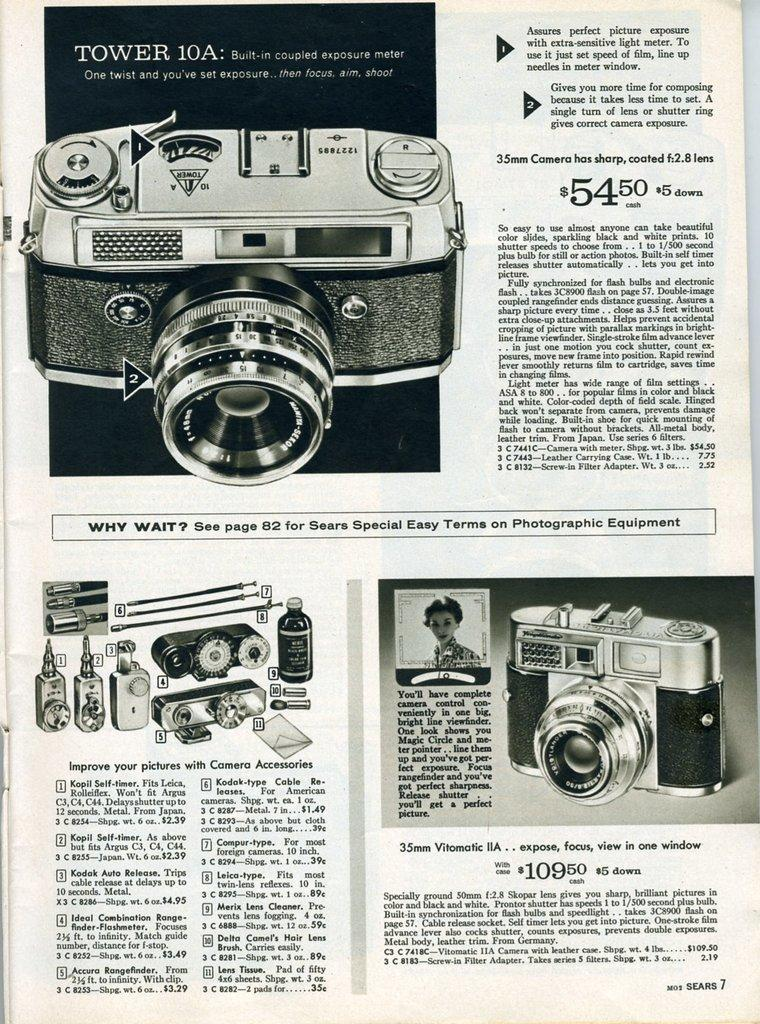What is the main subject of the page in the image? The page contains information about a camera. What type of kite is being used to take pictures in the image? There is no kite present in the image; the page contains information about a camera. Can you tell me how many apples are mentioned in the image? There is no mention of apples or produce in the image; the page contains information about a camera. 